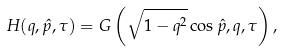Convert formula to latex. <formula><loc_0><loc_0><loc_500><loc_500>H ( q , \hat { p } , \tau ) = G \left ( \sqrt { 1 - q ^ { 2 } } \cos \hat { p } , q , \tau \right ) ,</formula> 